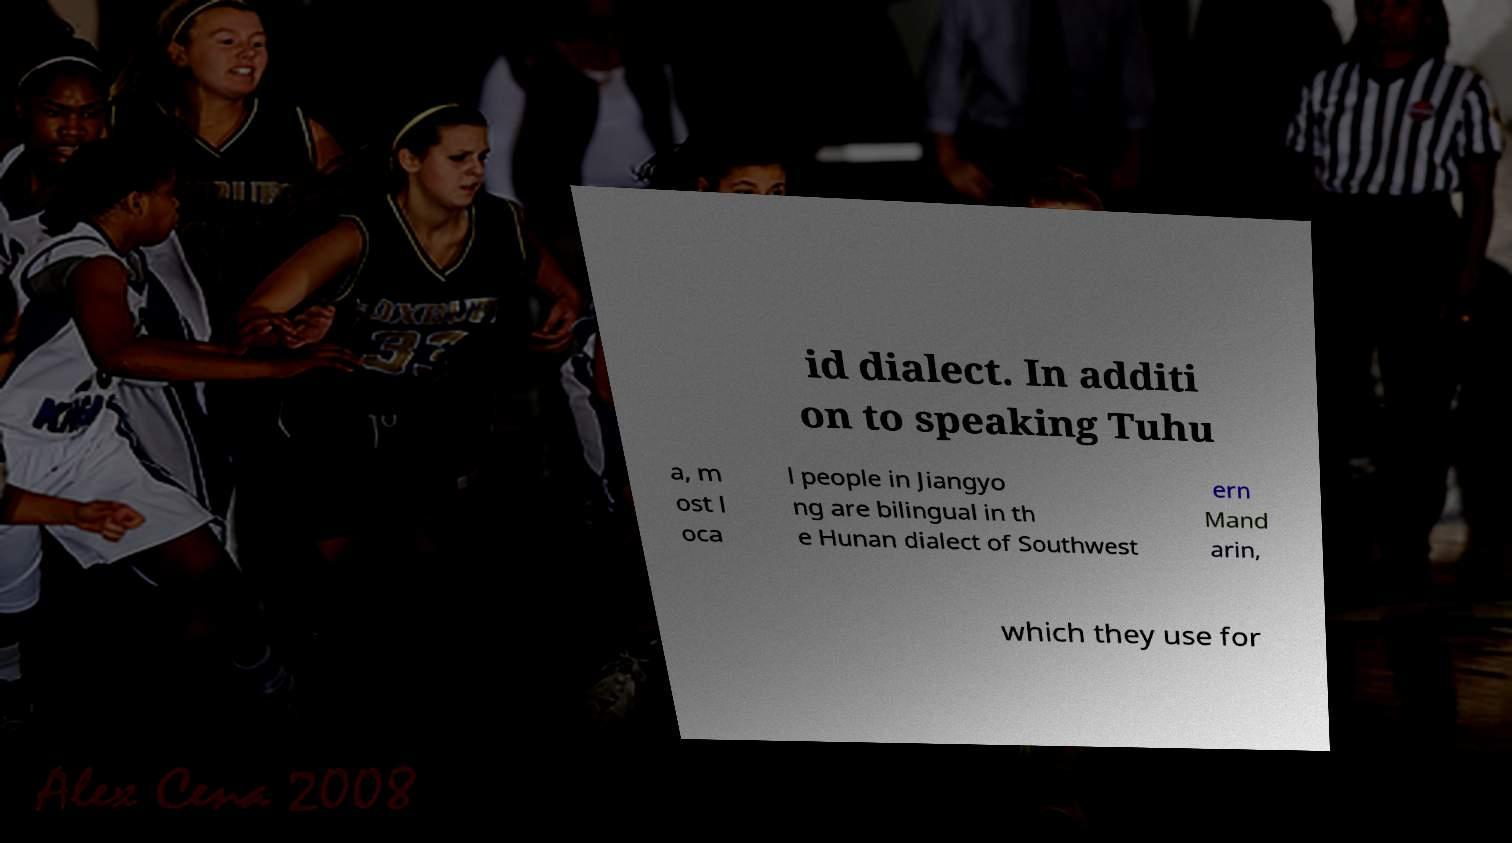Can you accurately transcribe the text from the provided image for me? id dialect. In additi on to speaking Tuhu a, m ost l oca l people in Jiangyo ng are bilingual in th e Hunan dialect of Southwest ern Mand arin, which they use for 